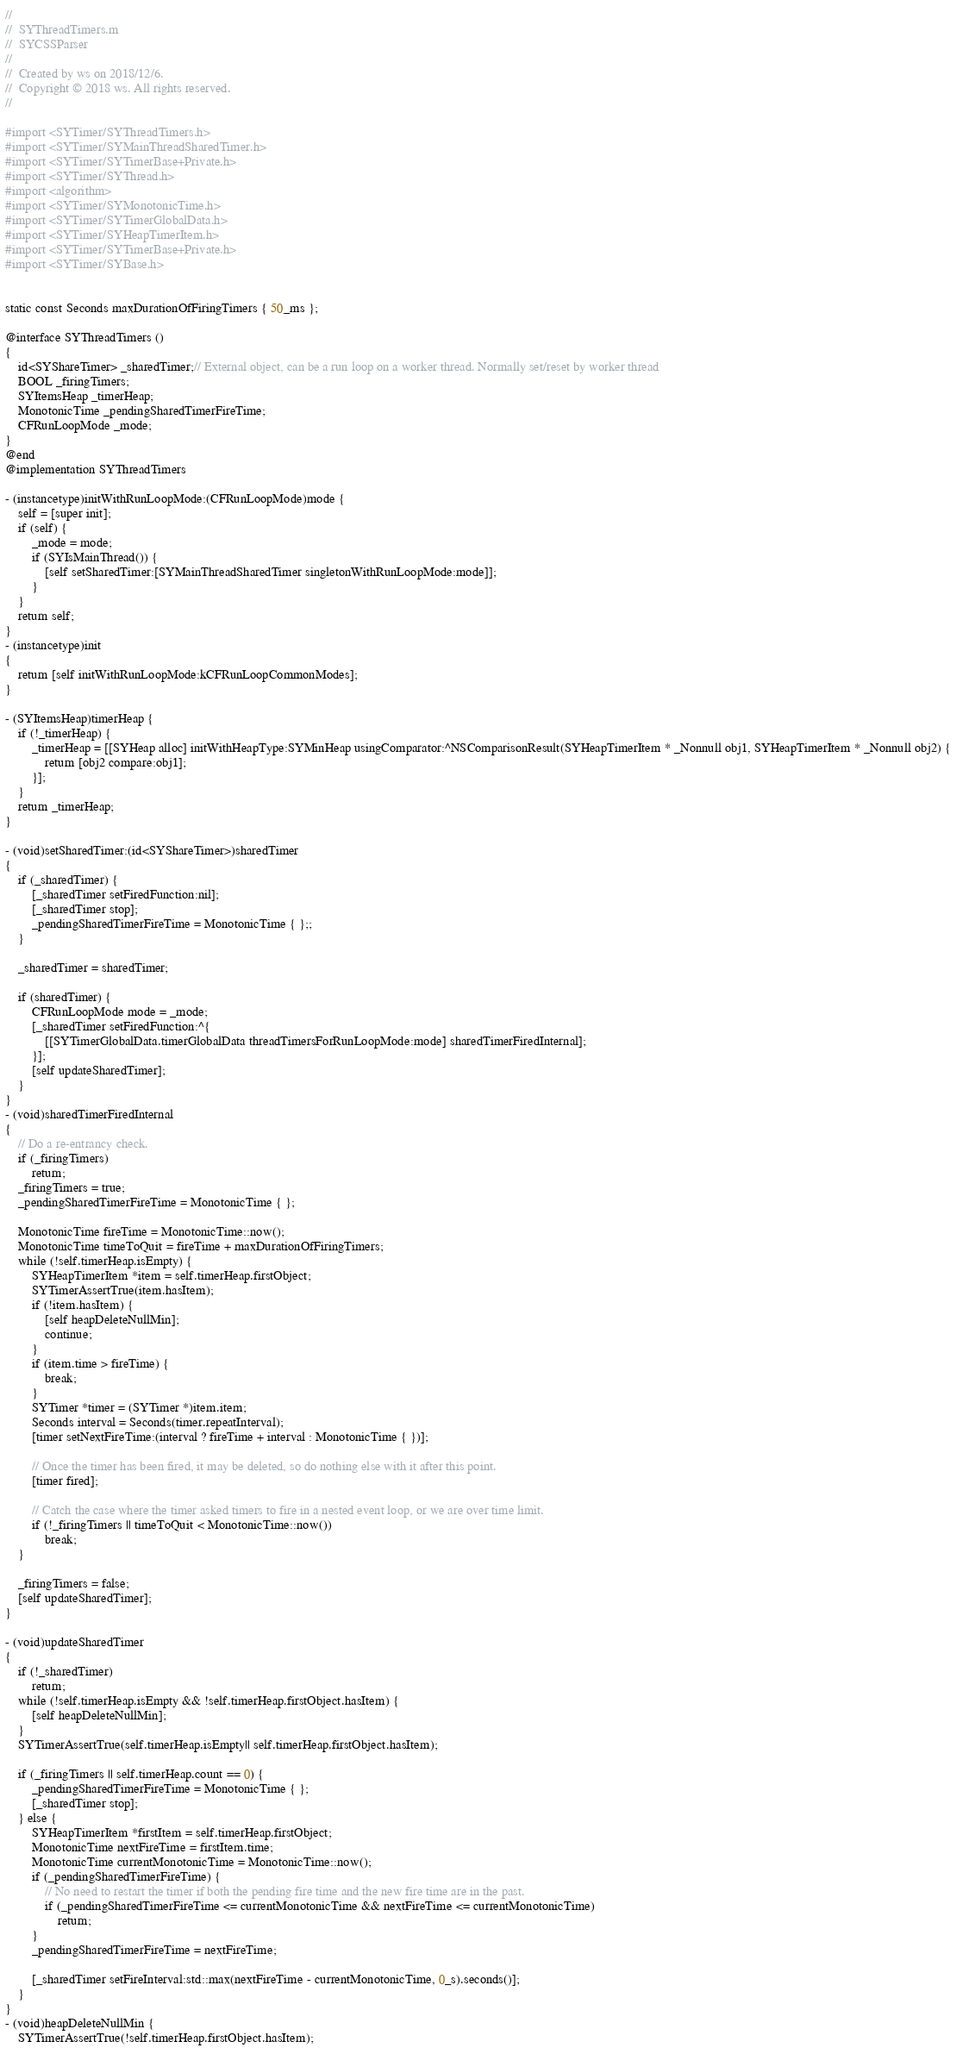Convert code to text. <code><loc_0><loc_0><loc_500><loc_500><_ObjectiveC_>
//
//  SYThreadTimers.m
//  SYCSSParser
//
//  Created by ws on 2018/12/6.
//  Copyright © 2018 ws. All rights reserved.
//

#import <SYTimer/SYThreadTimers.h>
#import <SYTimer/SYMainThreadSharedTimer.h>
#import <SYTimer/SYTimerBase+Private.h>
#import <SYTimer/SYThread.h>
#import <algorithm>
#import <SYTimer/SYMonotonicTime.h>
#import <SYTimer/SYTimerGlobalData.h>
#import <SYTimer/SYHeapTimerItem.h>
#import <SYTimer/SYTimerBase+Private.h>
#import <SYTimer/SYBase.h>


static const Seconds maxDurationOfFiringTimers { 50_ms };

@interface SYThreadTimers ()
{
    id<SYShareTimer> _sharedTimer;// External object, can be a run loop on a worker thread. Normally set/reset by worker thread
    BOOL _firingTimers;
    SYItemsHeap _timerHeap;
    MonotonicTime _pendingSharedTimerFireTime;
    CFRunLoopMode _mode;
}
@end
@implementation SYThreadTimers

- (instancetype)initWithRunLoopMode:(CFRunLoopMode)mode {
    self = [super init];
    if (self) {
        _mode = mode;
        if (SYIsMainThread()) {
            [self setSharedTimer:[SYMainThreadSharedTimer singletonWithRunLoopMode:mode]];
        }
    }
    return self;
}
- (instancetype)init
{
    return [self initWithRunLoopMode:kCFRunLoopCommonModes];
}

- (SYItemsHeap)timerHeap {
    if (!_timerHeap) {
        _timerHeap = [[SYHeap alloc] initWithHeapType:SYMinHeap usingComparator:^NSComparisonResult(SYHeapTimerItem * _Nonnull obj1, SYHeapTimerItem * _Nonnull obj2) {
            return [obj2 compare:obj1];
        }];
    }
    return _timerHeap;
}

- (void)setSharedTimer:(id<SYShareTimer>)sharedTimer
{
    if (_sharedTimer) {
        [_sharedTimer setFiredFunction:nil];
        [_sharedTimer stop];
        _pendingSharedTimerFireTime = MonotonicTime { };;
    }
    
    _sharedTimer = sharedTimer;
    
    if (sharedTimer) {
        CFRunLoopMode mode = _mode;
        [_sharedTimer setFiredFunction:^{
            [[SYTimerGlobalData.timerGlobalData threadTimersForRunLoopMode:mode] sharedTimerFiredInternal];
        }];
        [self updateSharedTimer];
    }
}
- (void)sharedTimerFiredInternal
{
    // Do a re-entrancy check.
    if (_firingTimers)
        return;
    _firingTimers = true;
    _pendingSharedTimerFireTime = MonotonicTime { };
    
    MonotonicTime fireTime = MonotonicTime::now();
    MonotonicTime timeToQuit = fireTime + maxDurationOfFiringTimers;
    while (!self.timerHeap.isEmpty) {
        SYHeapTimerItem *item = self.timerHeap.firstObject;
        SYTimerAssertTrue(item.hasItem);
        if (!item.hasItem) {
            [self heapDeleteNullMin];
            continue;
        }
        if (item.time > fireTime) {
            break;
        }
        SYTimer *timer = (SYTimer *)item.item;
        Seconds interval = Seconds(timer.repeatInterval);
        [timer setNextFireTime:(interval ? fireTime + interval : MonotonicTime { })];
        
        // Once the timer has been fired, it may be deleted, so do nothing else with it after this point.
        [timer fired];
        
        // Catch the case where the timer asked timers to fire in a nested event loop, or we are over time limit.
        if (!_firingTimers || timeToQuit < MonotonicTime::now())
            break;
    }
    
    _firingTimers = false;
    [self updateSharedTimer];
}

- (void)updateSharedTimer
{
    if (!_sharedTimer)
        return;
    while (!self.timerHeap.isEmpty && !self.timerHeap.firstObject.hasItem) {
        [self heapDeleteNullMin];
    }
    SYTimerAssertTrue(self.timerHeap.isEmpty|| self.timerHeap.firstObject.hasItem);

    if (_firingTimers || self.timerHeap.count == 0) {
        _pendingSharedTimerFireTime = MonotonicTime { };
        [_sharedTimer stop];
    } else {
        SYHeapTimerItem *firstItem = self.timerHeap.firstObject;
        MonotonicTime nextFireTime = firstItem.time;
        MonotonicTime currentMonotonicTime = MonotonicTime::now();
        if (_pendingSharedTimerFireTime) {
            // No need to restart the timer if both the pending fire time and the new fire time are in the past.
            if (_pendingSharedTimerFireTime <= currentMonotonicTime && nextFireTime <= currentMonotonicTime)
                return;
        }
        _pendingSharedTimerFireTime = nextFireTime;
        
        [_sharedTimer setFireInterval:std::max(nextFireTime - currentMonotonicTime, 0_s).seconds()];
    }
}
- (void)heapDeleteNullMin {
    SYTimerAssertTrue(!self.timerHeap.firstObject.hasItem);</code> 